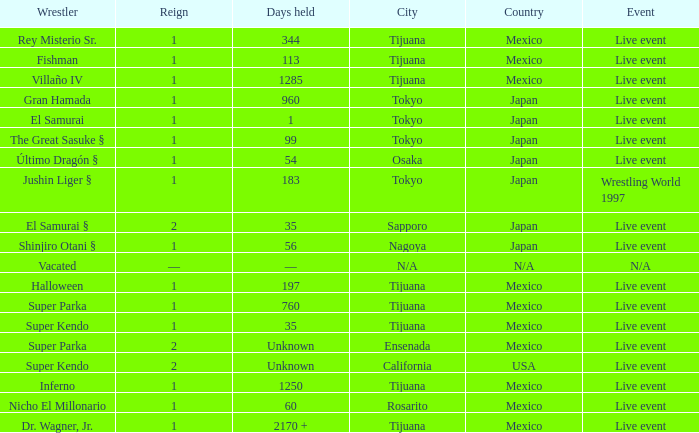What is the reign for super kendo who held it for 35 days? 1.0. 